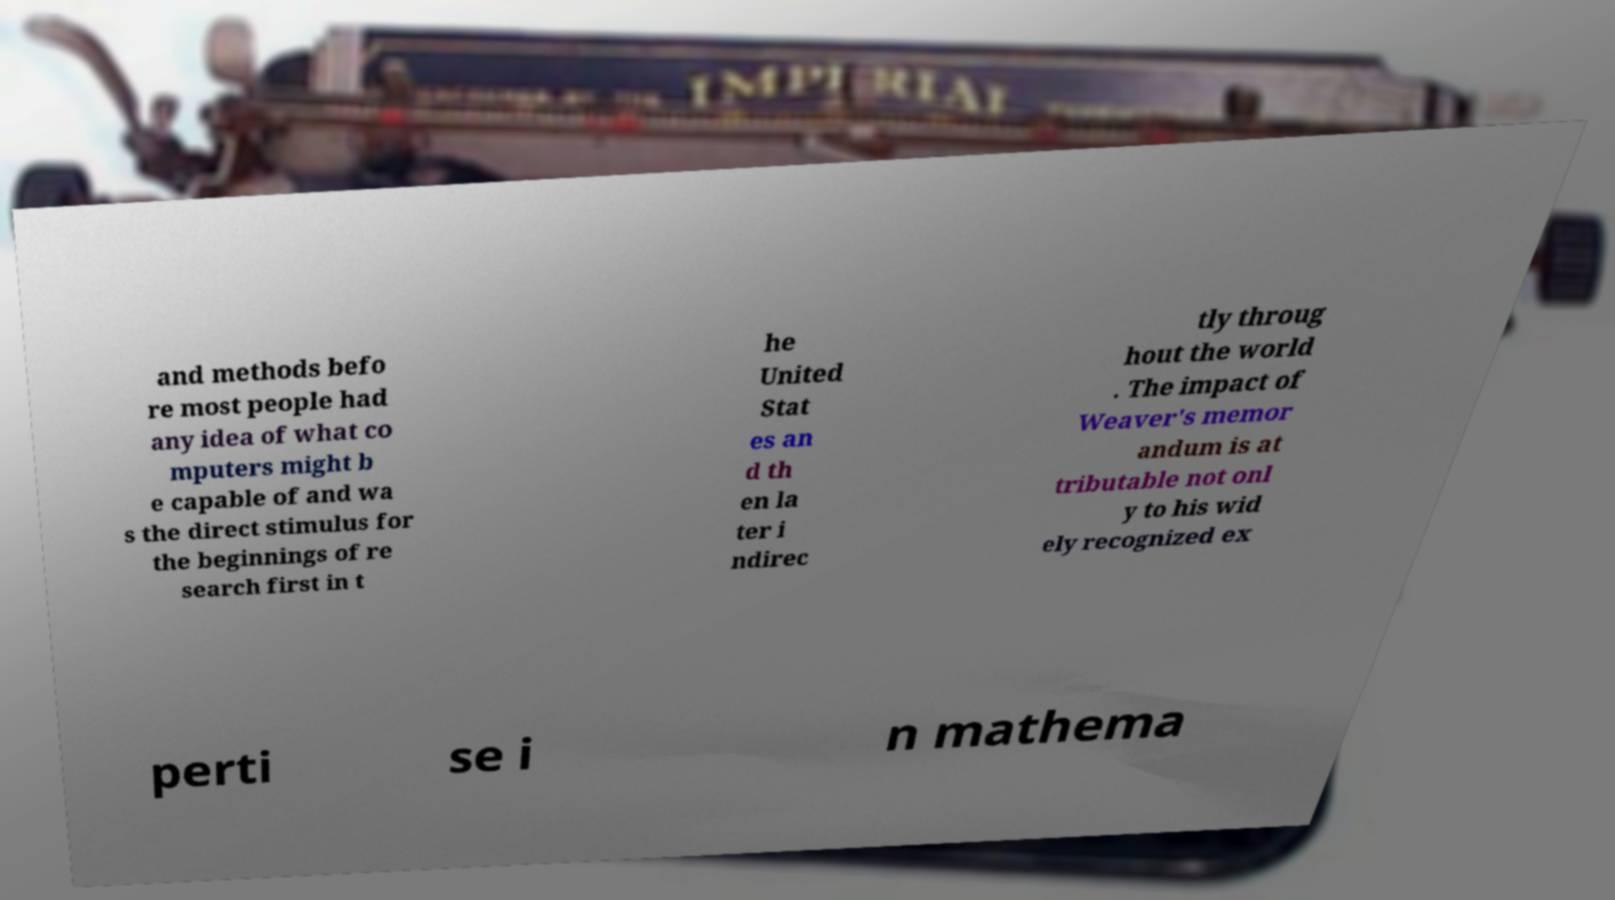For documentation purposes, I need the text within this image transcribed. Could you provide that? and methods befo re most people had any idea of what co mputers might b e capable of and wa s the direct stimulus for the beginnings of re search first in t he United Stat es an d th en la ter i ndirec tly throug hout the world . The impact of Weaver's memor andum is at tributable not onl y to his wid ely recognized ex perti se i n mathema 